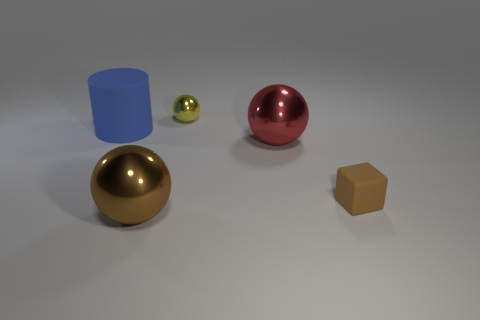Are the sizes of these objects indicative of their real-world dimensions? The sizes of these objects in the image do not necessarily represent their real-world dimensions. This looks like a staged scene, possibly for illustrative purposes, so the objects could have been scaled to fit the composition. They are likely chosen to represent different shapes and textures, rather than their actual sizes in real life. 